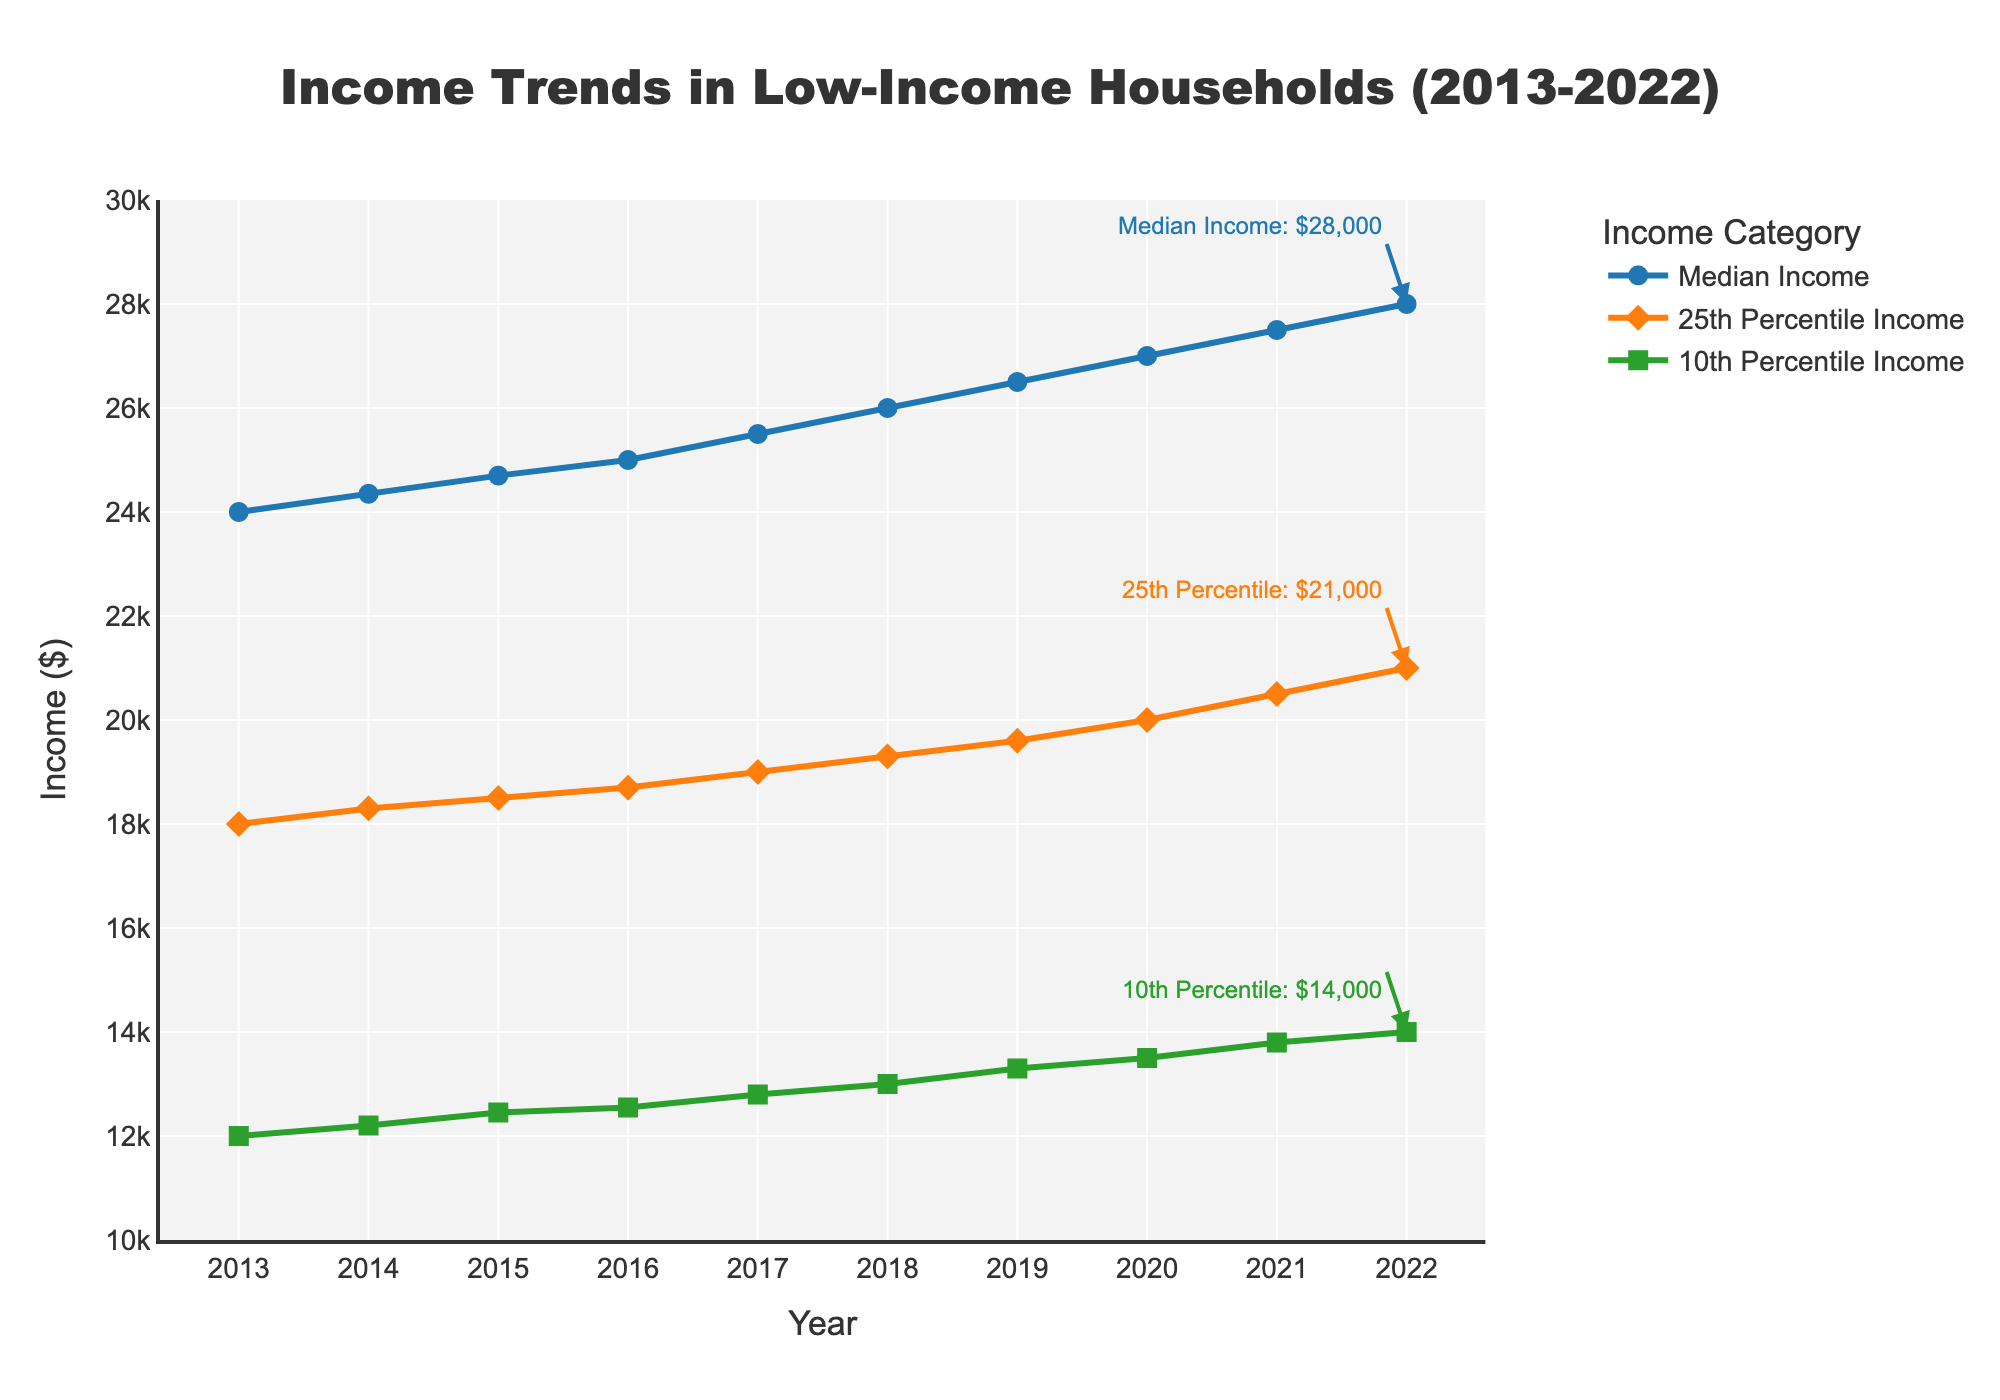How many years does the plot cover? The x-axis of the plot shows the range from 2013 to 2022, indicating the plot covers a total of 10 years.
Answer: 10 years What's the highest median income displayed on the plot? The plot shows that the highest median income is in 2022, with the value of $28,000 highlighted by the annotation.
Answer: $28,000 How much did the 10th percentile income increase from 2013 to 2022? In 2013, the 10th percentile income was $12,000. In 2022, it is $14,000. The increase is \( 14,000 - 12,000 \) dollars.
Answer: $2,000 Which year had the smallest increase in median income compared to the previous year? By examining the changes for each year, the difference between 2013 ($24,000) and 2014 ($24,350) is the smallest, an increase of $350.
Answer: 2014 What is the average 25th percentile income over the decade? The 25th percentile incomes from 2013 to 2022 are: 18,000, 18,300, 18,500, 18,700, 19,000, 19,300, 19,600, 20,000, 20,500, 21,000. Summing these values gives 192,900, and dividing by 10 years, the average is \( 192,900 / 10 \).
Answer: $19,290 Which income category saw the largest absolute increase from 2013 to 2022? The median income increased from $24,000 to $28,000, a $4,000 increase. The 10th percentile income increased by $2,000 ($12,000 to $14,000), and the 25th percentile by $3,000 ($18,000 to $21,000). The median income saw the largest absolute increase.
Answer: Median Income In what year did the median income reach $26,000? According to the plot, in the year 2018, the median income reached $26,000.
Answer: 2018 How does the trend of 10th percentile income compare to the trend of 25th percentile income? Both 10th and 25th percentile incomes show an increasing trend from 2013 to 2022. However, the 25th percentile has a steeper increase in comparison to the 10th percentile.
Answer: 25th percentile increase is steeper Does any year have a 25th percentile income smaller than the 10th percentile income of another year? The lowest 25th percentile income is $18,000 (2013), while the highest 10th percentile is $14,000 (2022). There is no overlap where the 25th percentile income is smaller than the 10th percentile income of another year.
Answer: No What was the income gap between the 25th percentile and the median for the year 2017? In 2017, the 25th percentile income is $19,000 and the median income is $25,500. The gap is calculated as \( 25,500 - 19,000 \).
Answer: $6,500 